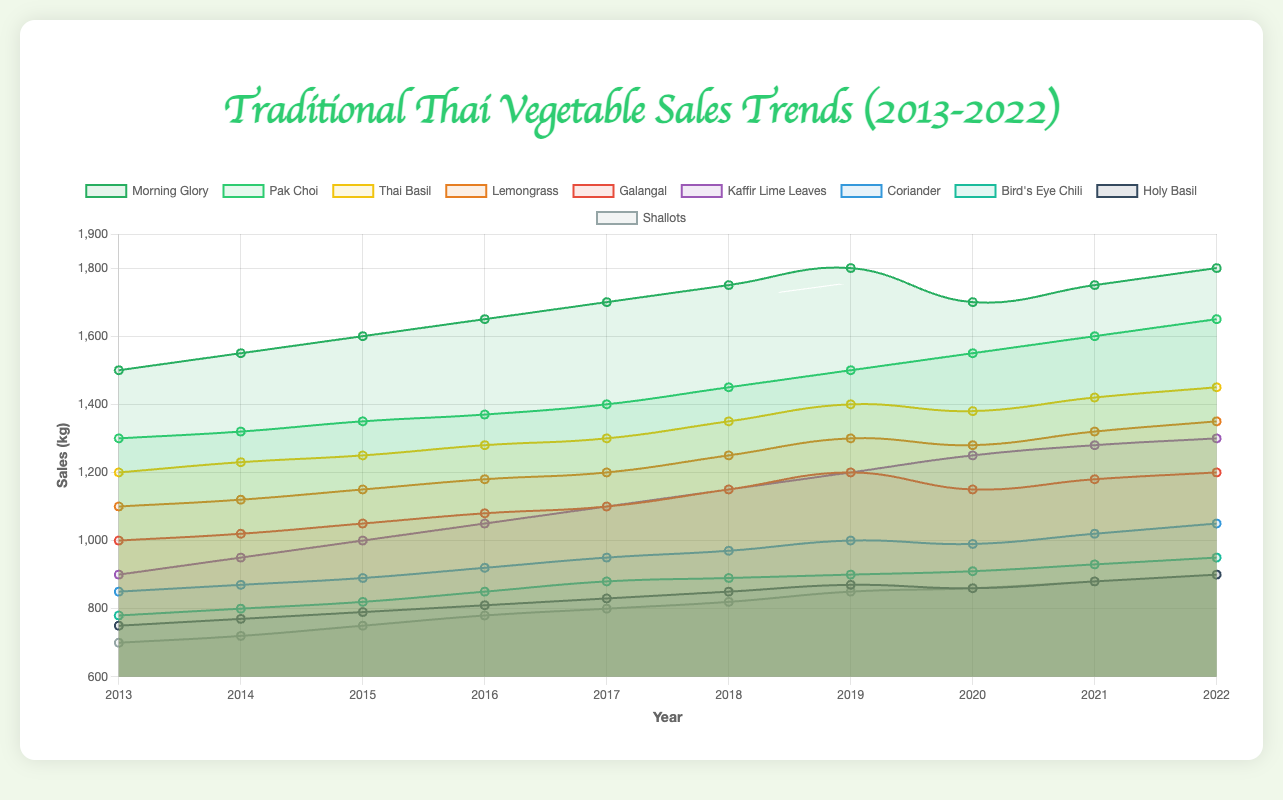Which vegetable had the lowest sales in 2013? To determine the vegetable with the lowest sales in 2013, we look at the sales data for each vegetable in that year. The sales for each vegetable are: Morning Glory (1500), Pak Choi (1300), Thai Basil (1200), Lemongrass (1100), Galangal (1000), Kaffir Lime Leaves (900), Coriander (850), Bird's Eye Chili (780), Holy Basil (750), and Shallots (700). Shallots have the lowest sales in 2013.
Answer: Shallots Which vegetable showed the most significant increase in sales from 2013 to 2022? To find the vegetable with the most significant increase, we calculate the difference in sales between 2013 and 2022 for each vegetable: Morning Glory (300), Pak Choi (350), Thai Basil (250), Lemongrass (250), Galangal (200), Kaffir Lime Leaves (400), Coriander (200), Bird's Eye Chili (170), Holy Basil (150), and Shallots (200). Kaffir Lime Leaves has the highest increase with 400 kg.
Answer: Kaffir Lime Leaves During which year did Morning Glory experience a drop in sales compared to the previous year? Examining the sales of Morning Glory year by year, we notice that sales dropped from 1800 kg in 2019 to 1700 kg in 2020. This is the only year where a decrease occurred compared to the previous year.
Answer: 2020 Between 2017 and 2019, which vegetable had the greatest sales growth? To find the vegetable with the greatest growth between 2017 and 2019, we calculate the difference in sales for each vegetable between these years: Morning Glory (100), Pak Choi (100), Thai Basil (100), Lemongrass (100), Galangal (100), Kaffir Lime Leaves (100), Coriander (50), Bird's Eye Chili (20), Holy Basil (40), and Shallots (50). The vegetables all have similar growth, but six of them grow by 100 kg each.
Answer: Multiple vegetables (Morning Glory, Pak Choi, Thai Basil, Lemongrass, Galangal, Kaffir Lime Leaves) What is the combined sales figure for Galangal and Lemongrass in 2022? The combined sales figure for Galangal and Lemongrass in 2022 is the sum of their individual sales: Galangal (1200) and Lemongrass (1350). Therefore, the total sales are 1200 + 1350 = 2550 kg.
Answer: 2550 kg Which vegetable had more consistent sales over the decade, Coriander or Bird's Eye Chili? Consistency can be evaluated by examining the year-over-year changes. For Coriander, the sales move from 850 to 1050; for Bird's Eye Chili, sales move from 780 to 950. Despite slight annual variations, Bird's Eye Chili shows more consistent year-over-year growth without any significant drops, unlike Coriander which dips slightly in 2020.
Answer: Bird's Eye Chili What year did Lemongrass reach its highest sales and how much were they? Reviewing Lemongrass sales, the highest value is 1350 kg in 2022.
Answer: 2022, 1350 kg Comparatively, which vegetable had higher sales in 2018, Thai Basil or Galangal? In 2018, Thai Basil had sales of 1350 kg, whereas Galangal had sales of 1150 kg. Therefore, Thai Basil had higher sales.
Answer: Thai Basil On average, how much did the sales of Kaffir Lime Leaves increase per year over the decade? The total increase in sales for Kaffir Lime Leaves from 2013 to 2022 is 1300 - 900 = 400 kg. Over 9 intervals (2013 to 2022 covers 9 years), the average annual increase is 400 / 9 ≈ 44.44 kg.
Answer: Approximately 44.44 kg per year 